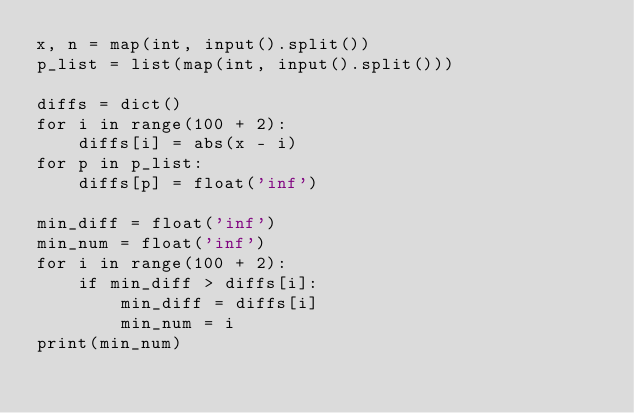<code> <loc_0><loc_0><loc_500><loc_500><_Python_>x, n = map(int, input().split())
p_list = list(map(int, input().split()))

diffs = dict()
for i in range(100 + 2):
    diffs[i] = abs(x - i)
for p in p_list:
    diffs[p] = float('inf')

min_diff = float('inf')
min_num = float('inf')
for i in range(100 + 2):
    if min_diff > diffs[i]:
        min_diff = diffs[i]
        min_num = i
print(min_num)</code> 